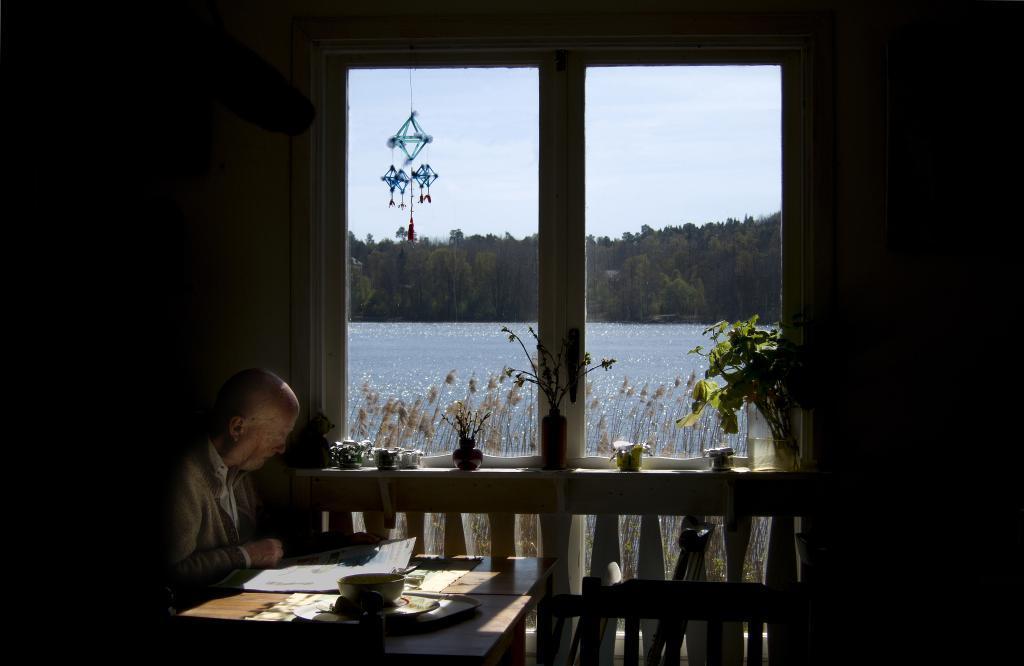Could you give a brief overview of what you see in this image? There is a man sitting in the chair in front of a table on which a paper, bowl was placed. There is a window in this room in front of which some plants were placed. In the background there is a water, trees and a sky here. 